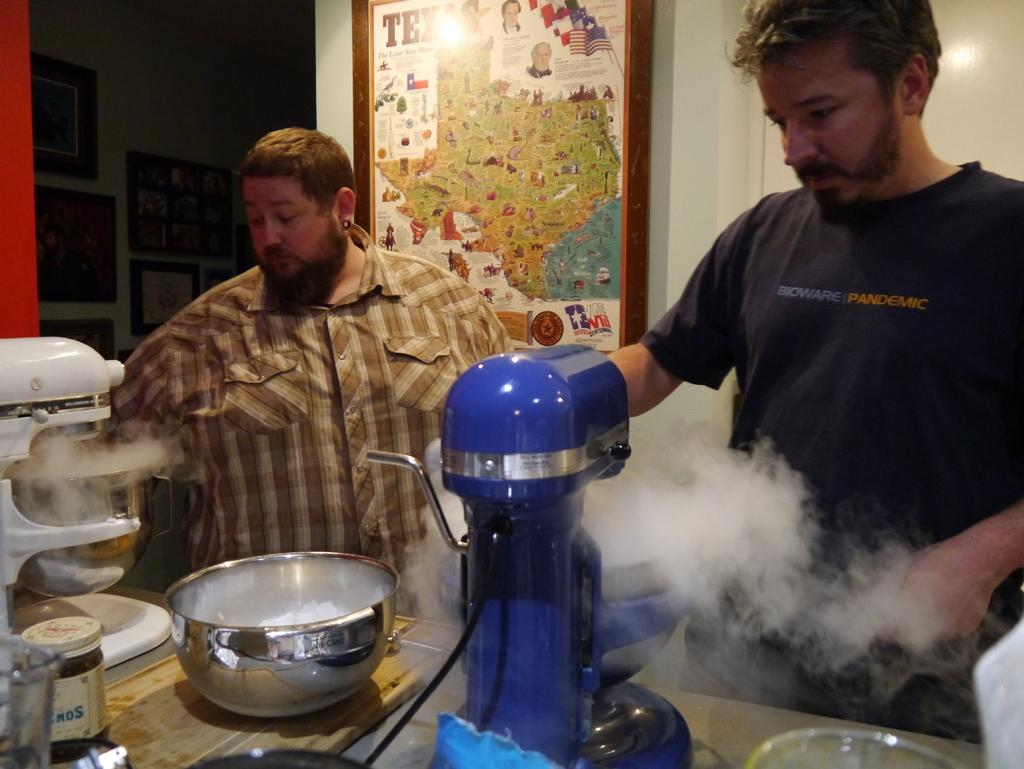<image>
Give a short and clear explanation of the subsequent image. A man wearing a tshirt that says Bioware Pandemic prepares food with another man in a plaid shirt who is standing in front of  a Texas map. 